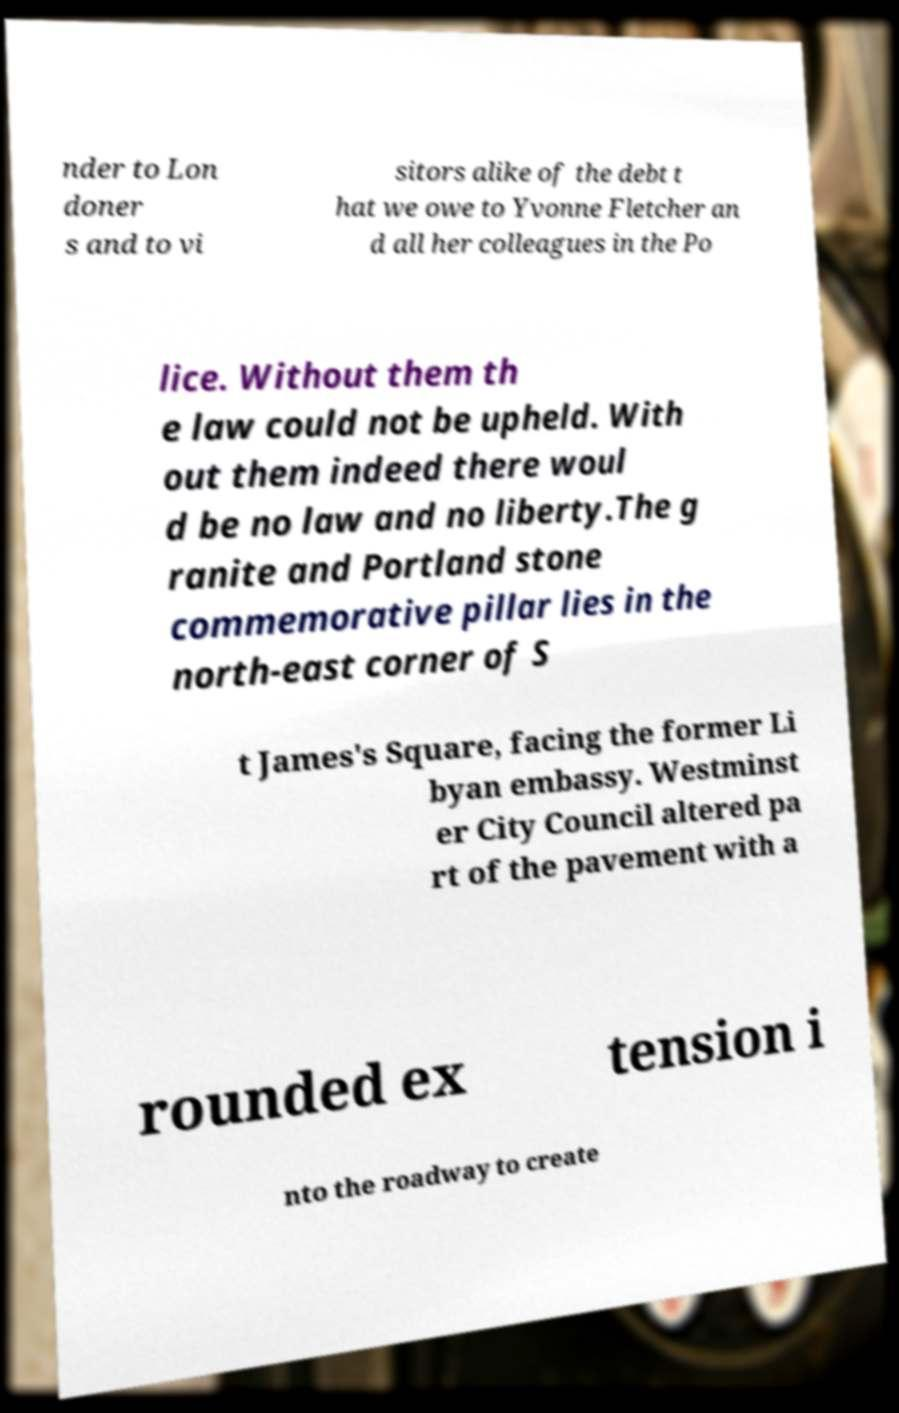I need the written content from this picture converted into text. Can you do that? nder to Lon doner s and to vi sitors alike of the debt t hat we owe to Yvonne Fletcher an d all her colleagues in the Po lice. Without them th e law could not be upheld. With out them indeed there woul d be no law and no liberty.The g ranite and Portland stone commemorative pillar lies in the north-east corner of S t James's Square, facing the former Li byan embassy. Westminst er City Council altered pa rt of the pavement with a rounded ex tension i nto the roadway to create 